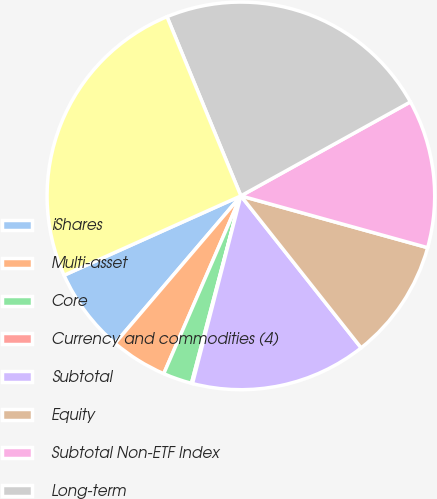Convert chart. <chart><loc_0><loc_0><loc_500><loc_500><pie_chart><fcel>iShares<fcel>Multi-asset<fcel>Core<fcel>Currency and commodities (4)<fcel>Subtotal<fcel>Equity<fcel>Subtotal Non-ETF Index<fcel>Long-term<fcel>Total<nl><fcel>7.04%<fcel>4.73%<fcel>2.41%<fcel>0.09%<fcel>14.67%<fcel>10.04%<fcel>12.36%<fcel>23.17%<fcel>25.49%<nl></chart> 